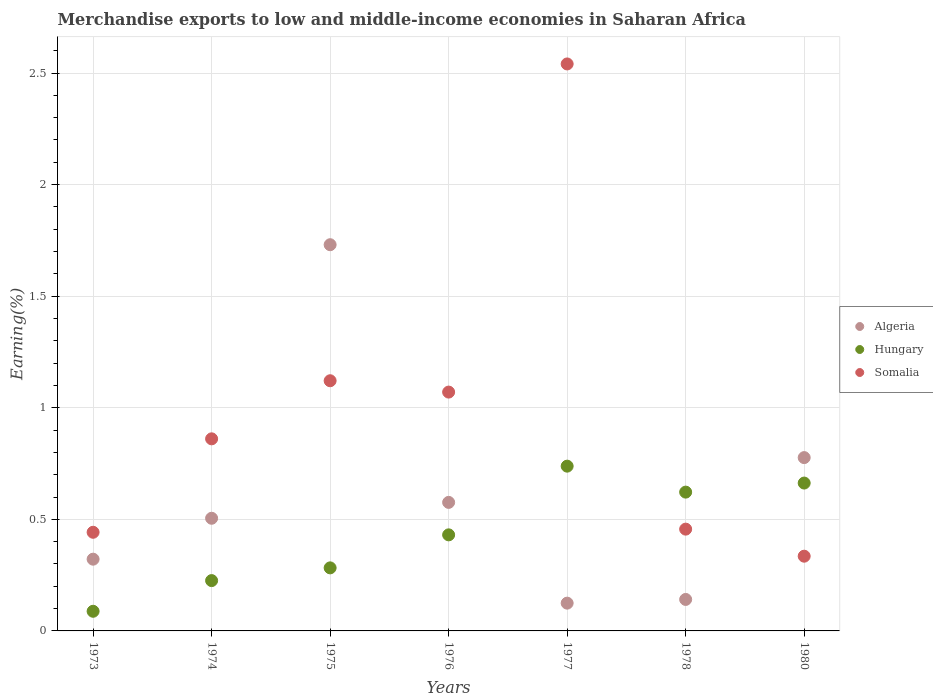What is the percentage of amount earned from merchandise exports in Somalia in 1974?
Your answer should be compact. 0.86. Across all years, what is the maximum percentage of amount earned from merchandise exports in Hungary?
Your answer should be compact. 0.74. Across all years, what is the minimum percentage of amount earned from merchandise exports in Algeria?
Provide a succinct answer. 0.12. What is the total percentage of amount earned from merchandise exports in Somalia in the graph?
Your answer should be very brief. 6.83. What is the difference between the percentage of amount earned from merchandise exports in Somalia in 1976 and that in 1977?
Make the answer very short. -1.47. What is the difference between the percentage of amount earned from merchandise exports in Hungary in 1975 and the percentage of amount earned from merchandise exports in Somalia in 1978?
Offer a terse response. -0.17. What is the average percentage of amount earned from merchandise exports in Hungary per year?
Make the answer very short. 0.44. In the year 1977, what is the difference between the percentage of amount earned from merchandise exports in Algeria and percentage of amount earned from merchandise exports in Hungary?
Ensure brevity in your answer.  -0.61. In how many years, is the percentage of amount earned from merchandise exports in Hungary greater than 2 %?
Offer a terse response. 0. What is the ratio of the percentage of amount earned from merchandise exports in Hungary in 1973 to that in 1978?
Your answer should be compact. 0.14. Is the difference between the percentage of amount earned from merchandise exports in Algeria in 1978 and 1980 greater than the difference between the percentage of amount earned from merchandise exports in Hungary in 1978 and 1980?
Ensure brevity in your answer.  No. What is the difference between the highest and the second highest percentage of amount earned from merchandise exports in Somalia?
Give a very brief answer. 1.42. What is the difference between the highest and the lowest percentage of amount earned from merchandise exports in Hungary?
Your answer should be very brief. 0.65. In how many years, is the percentage of amount earned from merchandise exports in Algeria greater than the average percentage of amount earned from merchandise exports in Algeria taken over all years?
Provide a succinct answer. 2. Does the percentage of amount earned from merchandise exports in Algeria monotonically increase over the years?
Your answer should be very brief. No. Is the percentage of amount earned from merchandise exports in Hungary strictly greater than the percentage of amount earned from merchandise exports in Somalia over the years?
Your answer should be compact. No. Is the percentage of amount earned from merchandise exports in Hungary strictly less than the percentage of amount earned from merchandise exports in Somalia over the years?
Make the answer very short. No. How many years are there in the graph?
Offer a very short reply. 7. What is the difference between two consecutive major ticks on the Y-axis?
Your response must be concise. 0.5. Are the values on the major ticks of Y-axis written in scientific E-notation?
Give a very brief answer. No. Does the graph contain grids?
Give a very brief answer. Yes. Where does the legend appear in the graph?
Provide a succinct answer. Center right. How many legend labels are there?
Provide a short and direct response. 3. How are the legend labels stacked?
Your response must be concise. Vertical. What is the title of the graph?
Offer a terse response. Merchandise exports to low and middle-income economies in Saharan Africa. What is the label or title of the Y-axis?
Make the answer very short. Earning(%). What is the Earning(%) of Algeria in 1973?
Ensure brevity in your answer.  0.32. What is the Earning(%) of Hungary in 1973?
Your answer should be very brief. 0.09. What is the Earning(%) of Somalia in 1973?
Make the answer very short. 0.44. What is the Earning(%) of Algeria in 1974?
Provide a short and direct response. 0.5. What is the Earning(%) in Hungary in 1974?
Your answer should be compact. 0.23. What is the Earning(%) in Somalia in 1974?
Keep it short and to the point. 0.86. What is the Earning(%) in Algeria in 1975?
Provide a succinct answer. 1.73. What is the Earning(%) of Hungary in 1975?
Provide a succinct answer. 0.28. What is the Earning(%) of Somalia in 1975?
Give a very brief answer. 1.12. What is the Earning(%) of Algeria in 1976?
Provide a short and direct response. 0.58. What is the Earning(%) of Hungary in 1976?
Offer a very short reply. 0.43. What is the Earning(%) of Somalia in 1976?
Keep it short and to the point. 1.07. What is the Earning(%) in Algeria in 1977?
Keep it short and to the point. 0.12. What is the Earning(%) of Hungary in 1977?
Your answer should be very brief. 0.74. What is the Earning(%) in Somalia in 1977?
Offer a terse response. 2.54. What is the Earning(%) of Algeria in 1978?
Make the answer very short. 0.14. What is the Earning(%) in Hungary in 1978?
Ensure brevity in your answer.  0.62. What is the Earning(%) in Somalia in 1978?
Provide a short and direct response. 0.46. What is the Earning(%) in Algeria in 1980?
Provide a short and direct response. 0.78. What is the Earning(%) in Hungary in 1980?
Keep it short and to the point. 0.66. What is the Earning(%) of Somalia in 1980?
Provide a succinct answer. 0.33. Across all years, what is the maximum Earning(%) in Algeria?
Your response must be concise. 1.73. Across all years, what is the maximum Earning(%) of Hungary?
Your response must be concise. 0.74. Across all years, what is the maximum Earning(%) in Somalia?
Provide a short and direct response. 2.54. Across all years, what is the minimum Earning(%) in Algeria?
Offer a very short reply. 0.12. Across all years, what is the minimum Earning(%) in Hungary?
Keep it short and to the point. 0.09. Across all years, what is the minimum Earning(%) in Somalia?
Offer a very short reply. 0.33. What is the total Earning(%) of Algeria in the graph?
Provide a succinct answer. 4.18. What is the total Earning(%) of Hungary in the graph?
Your answer should be very brief. 3.05. What is the total Earning(%) of Somalia in the graph?
Offer a terse response. 6.83. What is the difference between the Earning(%) of Algeria in 1973 and that in 1974?
Provide a short and direct response. -0.18. What is the difference between the Earning(%) in Hungary in 1973 and that in 1974?
Provide a succinct answer. -0.14. What is the difference between the Earning(%) of Somalia in 1973 and that in 1974?
Provide a succinct answer. -0.42. What is the difference between the Earning(%) of Algeria in 1973 and that in 1975?
Make the answer very short. -1.41. What is the difference between the Earning(%) in Hungary in 1973 and that in 1975?
Offer a very short reply. -0.19. What is the difference between the Earning(%) of Somalia in 1973 and that in 1975?
Provide a short and direct response. -0.68. What is the difference between the Earning(%) in Algeria in 1973 and that in 1976?
Make the answer very short. -0.25. What is the difference between the Earning(%) in Hungary in 1973 and that in 1976?
Provide a succinct answer. -0.34. What is the difference between the Earning(%) of Somalia in 1973 and that in 1976?
Provide a short and direct response. -0.63. What is the difference between the Earning(%) of Algeria in 1973 and that in 1977?
Offer a terse response. 0.2. What is the difference between the Earning(%) of Hungary in 1973 and that in 1977?
Offer a terse response. -0.65. What is the difference between the Earning(%) of Somalia in 1973 and that in 1977?
Give a very brief answer. -2.1. What is the difference between the Earning(%) of Algeria in 1973 and that in 1978?
Offer a terse response. 0.18. What is the difference between the Earning(%) in Hungary in 1973 and that in 1978?
Offer a terse response. -0.53. What is the difference between the Earning(%) in Somalia in 1973 and that in 1978?
Ensure brevity in your answer.  -0.01. What is the difference between the Earning(%) of Algeria in 1973 and that in 1980?
Ensure brevity in your answer.  -0.46. What is the difference between the Earning(%) of Hungary in 1973 and that in 1980?
Your answer should be very brief. -0.57. What is the difference between the Earning(%) of Somalia in 1973 and that in 1980?
Give a very brief answer. 0.11. What is the difference between the Earning(%) in Algeria in 1974 and that in 1975?
Keep it short and to the point. -1.23. What is the difference between the Earning(%) in Hungary in 1974 and that in 1975?
Offer a terse response. -0.06. What is the difference between the Earning(%) in Somalia in 1974 and that in 1975?
Your response must be concise. -0.26. What is the difference between the Earning(%) in Algeria in 1974 and that in 1976?
Provide a succinct answer. -0.07. What is the difference between the Earning(%) of Hungary in 1974 and that in 1976?
Provide a succinct answer. -0.2. What is the difference between the Earning(%) of Somalia in 1974 and that in 1976?
Give a very brief answer. -0.21. What is the difference between the Earning(%) of Algeria in 1974 and that in 1977?
Offer a terse response. 0.38. What is the difference between the Earning(%) in Hungary in 1974 and that in 1977?
Your answer should be compact. -0.51. What is the difference between the Earning(%) of Somalia in 1974 and that in 1977?
Keep it short and to the point. -1.68. What is the difference between the Earning(%) of Algeria in 1974 and that in 1978?
Your answer should be very brief. 0.36. What is the difference between the Earning(%) in Hungary in 1974 and that in 1978?
Offer a very short reply. -0.4. What is the difference between the Earning(%) in Somalia in 1974 and that in 1978?
Your response must be concise. 0.4. What is the difference between the Earning(%) of Algeria in 1974 and that in 1980?
Make the answer very short. -0.27. What is the difference between the Earning(%) in Hungary in 1974 and that in 1980?
Offer a very short reply. -0.44. What is the difference between the Earning(%) of Somalia in 1974 and that in 1980?
Offer a very short reply. 0.53. What is the difference between the Earning(%) of Algeria in 1975 and that in 1976?
Provide a short and direct response. 1.15. What is the difference between the Earning(%) of Hungary in 1975 and that in 1976?
Keep it short and to the point. -0.15. What is the difference between the Earning(%) of Somalia in 1975 and that in 1976?
Make the answer very short. 0.05. What is the difference between the Earning(%) in Algeria in 1975 and that in 1977?
Give a very brief answer. 1.61. What is the difference between the Earning(%) of Hungary in 1975 and that in 1977?
Offer a terse response. -0.46. What is the difference between the Earning(%) of Somalia in 1975 and that in 1977?
Your answer should be compact. -1.42. What is the difference between the Earning(%) in Algeria in 1975 and that in 1978?
Your answer should be compact. 1.59. What is the difference between the Earning(%) of Hungary in 1975 and that in 1978?
Provide a short and direct response. -0.34. What is the difference between the Earning(%) in Somalia in 1975 and that in 1978?
Make the answer very short. 0.67. What is the difference between the Earning(%) in Algeria in 1975 and that in 1980?
Your answer should be very brief. 0.95. What is the difference between the Earning(%) of Hungary in 1975 and that in 1980?
Keep it short and to the point. -0.38. What is the difference between the Earning(%) in Somalia in 1975 and that in 1980?
Ensure brevity in your answer.  0.79. What is the difference between the Earning(%) in Algeria in 1976 and that in 1977?
Provide a succinct answer. 0.45. What is the difference between the Earning(%) of Hungary in 1976 and that in 1977?
Ensure brevity in your answer.  -0.31. What is the difference between the Earning(%) of Somalia in 1976 and that in 1977?
Ensure brevity in your answer.  -1.47. What is the difference between the Earning(%) in Algeria in 1976 and that in 1978?
Ensure brevity in your answer.  0.43. What is the difference between the Earning(%) of Hungary in 1976 and that in 1978?
Ensure brevity in your answer.  -0.19. What is the difference between the Earning(%) of Somalia in 1976 and that in 1978?
Keep it short and to the point. 0.61. What is the difference between the Earning(%) in Algeria in 1976 and that in 1980?
Make the answer very short. -0.2. What is the difference between the Earning(%) of Hungary in 1976 and that in 1980?
Your response must be concise. -0.23. What is the difference between the Earning(%) of Somalia in 1976 and that in 1980?
Provide a succinct answer. 0.74. What is the difference between the Earning(%) of Algeria in 1977 and that in 1978?
Keep it short and to the point. -0.02. What is the difference between the Earning(%) in Hungary in 1977 and that in 1978?
Offer a very short reply. 0.12. What is the difference between the Earning(%) in Somalia in 1977 and that in 1978?
Offer a very short reply. 2.08. What is the difference between the Earning(%) in Algeria in 1977 and that in 1980?
Give a very brief answer. -0.65. What is the difference between the Earning(%) in Hungary in 1977 and that in 1980?
Give a very brief answer. 0.08. What is the difference between the Earning(%) of Somalia in 1977 and that in 1980?
Offer a very short reply. 2.21. What is the difference between the Earning(%) of Algeria in 1978 and that in 1980?
Your answer should be very brief. -0.64. What is the difference between the Earning(%) in Hungary in 1978 and that in 1980?
Provide a succinct answer. -0.04. What is the difference between the Earning(%) in Somalia in 1978 and that in 1980?
Offer a terse response. 0.12. What is the difference between the Earning(%) of Algeria in 1973 and the Earning(%) of Hungary in 1974?
Provide a succinct answer. 0.1. What is the difference between the Earning(%) in Algeria in 1973 and the Earning(%) in Somalia in 1974?
Your answer should be very brief. -0.54. What is the difference between the Earning(%) of Hungary in 1973 and the Earning(%) of Somalia in 1974?
Offer a very short reply. -0.77. What is the difference between the Earning(%) of Algeria in 1973 and the Earning(%) of Hungary in 1975?
Your answer should be compact. 0.04. What is the difference between the Earning(%) in Algeria in 1973 and the Earning(%) in Somalia in 1975?
Your response must be concise. -0.8. What is the difference between the Earning(%) in Hungary in 1973 and the Earning(%) in Somalia in 1975?
Provide a succinct answer. -1.03. What is the difference between the Earning(%) in Algeria in 1973 and the Earning(%) in Hungary in 1976?
Your answer should be compact. -0.11. What is the difference between the Earning(%) of Algeria in 1973 and the Earning(%) of Somalia in 1976?
Your answer should be very brief. -0.75. What is the difference between the Earning(%) in Hungary in 1973 and the Earning(%) in Somalia in 1976?
Ensure brevity in your answer.  -0.98. What is the difference between the Earning(%) of Algeria in 1973 and the Earning(%) of Hungary in 1977?
Your response must be concise. -0.42. What is the difference between the Earning(%) in Algeria in 1973 and the Earning(%) in Somalia in 1977?
Ensure brevity in your answer.  -2.22. What is the difference between the Earning(%) in Hungary in 1973 and the Earning(%) in Somalia in 1977?
Offer a terse response. -2.45. What is the difference between the Earning(%) in Algeria in 1973 and the Earning(%) in Hungary in 1978?
Ensure brevity in your answer.  -0.3. What is the difference between the Earning(%) of Algeria in 1973 and the Earning(%) of Somalia in 1978?
Your answer should be compact. -0.13. What is the difference between the Earning(%) of Hungary in 1973 and the Earning(%) of Somalia in 1978?
Your response must be concise. -0.37. What is the difference between the Earning(%) of Algeria in 1973 and the Earning(%) of Hungary in 1980?
Offer a very short reply. -0.34. What is the difference between the Earning(%) of Algeria in 1973 and the Earning(%) of Somalia in 1980?
Ensure brevity in your answer.  -0.01. What is the difference between the Earning(%) in Hungary in 1973 and the Earning(%) in Somalia in 1980?
Provide a succinct answer. -0.25. What is the difference between the Earning(%) of Algeria in 1974 and the Earning(%) of Hungary in 1975?
Your answer should be compact. 0.22. What is the difference between the Earning(%) in Algeria in 1974 and the Earning(%) in Somalia in 1975?
Keep it short and to the point. -0.62. What is the difference between the Earning(%) of Hungary in 1974 and the Earning(%) of Somalia in 1975?
Give a very brief answer. -0.9. What is the difference between the Earning(%) of Algeria in 1974 and the Earning(%) of Hungary in 1976?
Your answer should be very brief. 0.07. What is the difference between the Earning(%) of Algeria in 1974 and the Earning(%) of Somalia in 1976?
Provide a succinct answer. -0.57. What is the difference between the Earning(%) in Hungary in 1974 and the Earning(%) in Somalia in 1976?
Offer a very short reply. -0.84. What is the difference between the Earning(%) of Algeria in 1974 and the Earning(%) of Hungary in 1977?
Offer a very short reply. -0.23. What is the difference between the Earning(%) of Algeria in 1974 and the Earning(%) of Somalia in 1977?
Keep it short and to the point. -2.04. What is the difference between the Earning(%) in Hungary in 1974 and the Earning(%) in Somalia in 1977?
Make the answer very short. -2.32. What is the difference between the Earning(%) of Algeria in 1974 and the Earning(%) of Hungary in 1978?
Keep it short and to the point. -0.12. What is the difference between the Earning(%) of Algeria in 1974 and the Earning(%) of Somalia in 1978?
Provide a succinct answer. 0.05. What is the difference between the Earning(%) in Hungary in 1974 and the Earning(%) in Somalia in 1978?
Your answer should be very brief. -0.23. What is the difference between the Earning(%) of Algeria in 1974 and the Earning(%) of Hungary in 1980?
Provide a succinct answer. -0.16. What is the difference between the Earning(%) in Algeria in 1974 and the Earning(%) in Somalia in 1980?
Ensure brevity in your answer.  0.17. What is the difference between the Earning(%) in Hungary in 1974 and the Earning(%) in Somalia in 1980?
Give a very brief answer. -0.11. What is the difference between the Earning(%) in Algeria in 1975 and the Earning(%) in Hungary in 1976?
Provide a succinct answer. 1.3. What is the difference between the Earning(%) in Algeria in 1975 and the Earning(%) in Somalia in 1976?
Your answer should be very brief. 0.66. What is the difference between the Earning(%) in Hungary in 1975 and the Earning(%) in Somalia in 1976?
Provide a succinct answer. -0.79. What is the difference between the Earning(%) in Algeria in 1975 and the Earning(%) in Somalia in 1977?
Ensure brevity in your answer.  -0.81. What is the difference between the Earning(%) of Hungary in 1975 and the Earning(%) of Somalia in 1977?
Offer a very short reply. -2.26. What is the difference between the Earning(%) in Algeria in 1975 and the Earning(%) in Hungary in 1978?
Provide a succinct answer. 1.11. What is the difference between the Earning(%) in Algeria in 1975 and the Earning(%) in Somalia in 1978?
Offer a very short reply. 1.27. What is the difference between the Earning(%) in Hungary in 1975 and the Earning(%) in Somalia in 1978?
Your answer should be very brief. -0.17. What is the difference between the Earning(%) of Algeria in 1975 and the Earning(%) of Hungary in 1980?
Your response must be concise. 1.07. What is the difference between the Earning(%) of Algeria in 1975 and the Earning(%) of Somalia in 1980?
Your response must be concise. 1.4. What is the difference between the Earning(%) of Hungary in 1975 and the Earning(%) of Somalia in 1980?
Keep it short and to the point. -0.05. What is the difference between the Earning(%) of Algeria in 1976 and the Earning(%) of Hungary in 1977?
Your answer should be very brief. -0.16. What is the difference between the Earning(%) of Algeria in 1976 and the Earning(%) of Somalia in 1977?
Keep it short and to the point. -1.96. What is the difference between the Earning(%) in Hungary in 1976 and the Earning(%) in Somalia in 1977?
Provide a succinct answer. -2.11. What is the difference between the Earning(%) in Algeria in 1976 and the Earning(%) in Hungary in 1978?
Provide a short and direct response. -0.05. What is the difference between the Earning(%) of Algeria in 1976 and the Earning(%) of Somalia in 1978?
Provide a short and direct response. 0.12. What is the difference between the Earning(%) of Hungary in 1976 and the Earning(%) of Somalia in 1978?
Give a very brief answer. -0.03. What is the difference between the Earning(%) of Algeria in 1976 and the Earning(%) of Hungary in 1980?
Provide a short and direct response. -0.09. What is the difference between the Earning(%) in Algeria in 1976 and the Earning(%) in Somalia in 1980?
Provide a short and direct response. 0.24. What is the difference between the Earning(%) in Hungary in 1976 and the Earning(%) in Somalia in 1980?
Your answer should be compact. 0.1. What is the difference between the Earning(%) in Algeria in 1977 and the Earning(%) in Hungary in 1978?
Your answer should be compact. -0.5. What is the difference between the Earning(%) of Algeria in 1977 and the Earning(%) of Somalia in 1978?
Provide a short and direct response. -0.33. What is the difference between the Earning(%) of Hungary in 1977 and the Earning(%) of Somalia in 1978?
Offer a terse response. 0.28. What is the difference between the Earning(%) in Algeria in 1977 and the Earning(%) in Hungary in 1980?
Your answer should be compact. -0.54. What is the difference between the Earning(%) of Algeria in 1977 and the Earning(%) of Somalia in 1980?
Offer a terse response. -0.21. What is the difference between the Earning(%) of Hungary in 1977 and the Earning(%) of Somalia in 1980?
Make the answer very short. 0.4. What is the difference between the Earning(%) in Algeria in 1978 and the Earning(%) in Hungary in 1980?
Make the answer very short. -0.52. What is the difference between the Earning(%) of Algeria in 1978 and the Earning(%) of Somalia in 1980?
Your answer should be compact. -0.19. What is the difference between the Earning(%) of Hungary in 1978 and the Earning(%) of Somalia in 1980?
Your answer should be compact. 0.29. What is the average Earning(%) of Algeria per year?
Your answer should be compact. 0.6. What is the average Earning(%) of Hungary per year?
Give a very brief answer. 0.44. What is the average Earning(%) in Somalia per year?
Your response must be concise. 0.98. In the year 1973, what is the difference between the Earning(%) of Algeria and Earning(%) of Hungary?
Provide a short and direct response. 0.23. In the year 1973, what is the difference between the Earning(%) in Algeria and Earning(%) in Somalia?
Offer a very short reply. -0.12. In the year 1973, what is the difference between the Earning(%) in Hungary and Earning(%) in Somalia?
Provide a succinct answer. -0.35. In the year 1974, what is the difference between the Earning(%) of Algeria and Earning(%) of Hungary?
Your answer should be very brief. 0.28. In the year 1974, what is the difference between the Earning(%) in Algeria and Earning(%) in Somalia?
Provide a short and direct response. -0.36. In the year 1974, what is the difference between the Earning(%) in Hungary and Earning(%) in Somalia?
Give a very brief answer. -0.64. In the year 1975, what is the difference between the Earning(%) of Algeria and Earning(%) of Hungary?
Offer a terse response. 1.45. In the year 1975, what is the difference between the Earning(%) in Algeria and Earning(%) in Somalia?
Make the answer very short. 0.61. In the year 1975, what is the difference between the Earning(%) in Hungary and Earning(%) in Somalia?
Make the answer very short. -0.84. In the year 1976, what is the difference between the Earning(%) in Algeria and Earning(%) in Hungary?
Your response must be concise. 0.15. In the year 1976, what is the difference between the Earning(%) of Algeria and Earning(%) of Somalia?
Ensure brevity in your answer.  -0.49. In the year 1976, what is the difference between the Earning(%) in Hungary and Earning(%) in Somalia?
Give a very brief answer. -0.64. In the year 1977, what is the difference between the Earning(%) of Algeria and Earning(%) of Hungary?
Provide a short and direct response. -0.61. In the year 1977, what is the difference between the Earning(%) in Algeria and Earning(%) in Somalia?
Offer a very short reply. -2.42. In the year 1977, what is the difference between the Earning(%) in Hungary and Earning(%) in Somalia?
Your answer should be very brief. -1.8. In the year 1978, what is the difference between the Earning(%) of Algeria and Earning(%) of Hungary?
Provide a succinct answer. -0.48. In the year 1978, what is the difference between the Earning(%) of Algeria and Earning(%) of Somalia?
Make the answer very short. -0.32. In the year 1978, what is the difference between the Earning(%) of Hungary and Earning(%) of Somalia?
Provide a short and direct response. 0.17. In the year 1980, what is the difference between the Earning(%) in Algeria and Earning(%) in Hungary?
Your answer should be very brief. 0.11. In the year 1980, what is the difference between the Earning(%) in Algeria and Earning(%) in Somalia?
Your response must be concise. 0.44. In the year 1980, what is the difference between the Earning(%) of Hungary and Earning(%) of Somalia?
Keep it short and to the point. 0.33. What is the ratio of the Earning(%) of Algeria in 1973 to that in 1974?
Ensure brevity in your answer.  0.64. What is the ratio of the Earning(%) of Hungary in 1973 to that in 1974?
Your answer should be compact. 0.39. What is the ratio of the Earning(%) in Somalia in 1973 to that in 1974?
Your answer should be compact. 0.51. What is the ratio of the Earning(%) in Algeria in 1973 to that in 1975?
Your answer should be compact. 0.19. What is the ratio of the Earning(%) of Hungary in 1973 to that in 1975?
Provide a short and direct response. 0.31. What is the ratio of the Earning(%) in Somalia in 1973 to that in 1975?
Your answer should be compact. 0.39. What is the ratio of the Earning(%) of Algeria in 1973 to that in 1976?
Provide a short and direct response. 0.56. What is the ratio of the Earning(%) of Hungary in 1973 to that in 1976?
Provide a short and direct response. 0.2. What is the ratio of the Earning(%) in Somalia in 1973 to that in 1976?
Provide a succinct answer. 0.41. What is the ratio of the Earning(%) in Algeria in 1973 to that in 1977?
Make the answer very short. 2.58. What is the ratio of the Earning(%) in Hungary in 1973 to that in 1977?
Offer a very short reply. 0.12. What is the ratio of the Earning(%) of Somalia in 1973 to that in 1977?
Give a very brief answer. 0.17. What is the ratio of the Earning(%) in Algeria in 1973 to that in 1978?
Make the answer very short. 2.28. What is the ratio of the Earning(%) of Hungary in 1973 to that in 1978?
Keep it short and to the point. 0.14. What is the ratio of the Earning(%) of Somalia in 1973 to that in 1978?
Make the answer very short. 0.97. What is the ratio of the Earning(%) in Algeria in 1973 to that in 1980?
Give a very brief answer. 0.41. What is the ratio of the Earning(%) of Hungary in 1973 to that in 1980?
Your answer should be compact. 0.13. What is the ratio of the Earning(%) of Somalia in 1973 to that in 1980?
Provide a succinct answer. 1.32. What is the ratio of the Earning(%) of Algeria in 1974 to that in 1975?
Your answer should be very brief. 0.29. What is the ratio of the Earning(%) of Hungary in 1974 to that in 1975?
Offer a very short reply. 0.8. What is the ratio of the Earning(%) in Somalia in 1974 to that in 1975?
Your response must be concise. 0.77. What is the ratio of the Earning(%) in Algeria in 1974 to that in 1976?
Make the answer very short. 0.88. What is the ratio of the Earning(%) in Hungary in 1974 to that in 1976?
Your answer should be compact. 0.52. What is the ratio of the Earning(%) in Somalia in 1974 to that in 1976?
Provide a short and direct response. 0.8. What is the ratio of the Earning(%) in Algeria in 1974 to that in 1977?
Offer a very short reply. 4.06. What is the ratio of the Earning(%) in Hungary in 1974 to that in 1977?
Give a very brief answer. 0.31. What is the ratio of the Earning(%) of Somalia in 1974 to that in 1977?
Keep it short and to the point. 0.34. What is the ratio of the Earning(%) in Algeria in 1974 to that in 1978?
Your answer should be very brief. 3.58. What is the ratio of the Earning(%) in Hungary in 1974 to that in 1978?
Your response must be concise. 0.36. What is the ratio of the Earning(%) in Somalia in 1974 to that in 1978?
Your answer should be very brief. 1.89. What is the ratio of the Earning(%) of Algeria in 1974 to that in 1980?
Keep it short and to the point. 0.65. What is the ratio of the Earning(%) in Hungary in 1974 to that in 1980?
Ensure brevity in your answer.  0.34. What is the ratio of the Earning(%) in Somalia in 1974 to that in 1980?
Keep it short and to the point. 2.57. What is the ratio of the Earning(%) of Algeria in 1975 to that in 1976?
Make the answer very short. 3. What is the ratio of the Earning(%) of Hungary in 1975 to that in 1976?
Your response must be concise. 0.66. What is the ratio of the Earning(%) of Somalia in 1975 to that in 1976?
Provide a short and direct response. 1.05. What is the ratio of the Earning(%) in Algeria in 1975 to that in 1977?
Keep it short and to the point. 13.9. What is the ratio of the Earning(%) of Hungary in 1975 to that in 1977?
Your response must be concise. 0.38. What is the ratio of the Earning(%) in Somalia in 1975 to that in 1977?
Ensure brevity in your answer.  0.44. What is the ratio of the Earning(%) in Algeria in 1975 to that in 1978?
Keep it short and to the point. 12.27. What is the ratio of the Earning(%) of Hungary in 1975 to that in 1978?
Provide a succinct answer. 0.45. What is the ratio of the Earning(%) in Somalia in 1975 to that in 1978?
Give a very brief answer. 2.46. What is the ratio of the Earning(%) of Algeria in 1975 to that in 1980?
Make the answer very short. 2.23. What is the ratio of the Earning(%) of Hungary in 1975 to that in 1980?
Provide a short and direct response. 0.43. What is the ratio of the Earning(%) in Somalia in 1975 to that in 1980?
Provide a short and direct response. 3.35. What is the ratio of the Earning(%) of Algeria in 1976 to that in 1977?
Provide a succinct answer. 4.63. What is the ratio of the Earning(%) of Hungary in 1976 to that in 1977?
Your answer should be very brief. 0.58. What is the ratio of the Earning(%) of Somalia in 1976 to that in 1977?
Your response must be concise. 0.42. What is the ratio of the Earning(%) in Algeria in 1976 to that in 1978?
Your answer should be very brief. 4.08. What is the ratio of the Earning(%) of Hungary in 1976 to that in 1978?
Make the answer very short. 0.69. What is the ratio of the Earning(%) in Somalia in 1976 to that in 1978?
Your answer should be very brief. 2.35. What is the ratio of the Earning(%) in Algeria in 1976 to that in 1980?
Give a very brief answer. 0.74. What is the ratio of the Earning(%) in Hungary in 1976 to that in 1980?
Provide a succinct answer. 0.65. What is the ratio of the Earning(%) in Somalia in 1976 to that in 1980?
Your response must be concise. 3.2. What is the ratio of the Earning(%) in Algeria in 1977 to that in 1978?
Your response must be concise. 0.88. What is the ratio of the Earning(%) of Hungary in 1977 to that in 1978?
Ensure brevity in your answer.  1.19. What is the ratio of the Earning(%) of Somalia in 1977 to that in 1978?
Provide a succinct answer. 5.57. What is the ratio of the Earning(%) of Algeria in 1977 to that in 1980?
Ensure brevity in your answer.  0.16. What is the ratio of the Earning(%) of Hungary in 1977 to that in 1980?
Offer a terse response. 1.11. What is the ratio of the Earning(%) in Somalia in 1977 to that in 1980?
Your answer should be compact. 7.59. What is the ratio of the Earning(%) in Algeria in 1978 to that in 1980?
Offer a very short reply. 0.18. What is the ratio of the Earning(%) of Hungary in 1978 to that in 1980?
Your answer should be compact. 0.94. What is the ratio of the Earning(%) in Somalia in 1978 to that in 1980?
Offer a terse response. 1.36. What is the difference between the highest and the second highest Earning(%) in Algeria?
Ensure brevity in your answer.  0.95. What is the difference between the highest and the second highest Earning(%) of Hungary?
Your response must be concise. 0.08. What is the difference between the highest and the second highest Earning(%) in Somalia?
Your answer should be very brief. 1.42. What is the difference between the highest and the lowest Earning(%) in Algeria?
Your answer should be very brief. 1.61. What is the difference between the highest and the lowest Earning(%) in Hungary?
Offer a terse response. 0.65. What is the difference between the highest and the lowest Earning(%) in Somalia?
Keep it short and to the point. 2.21. 